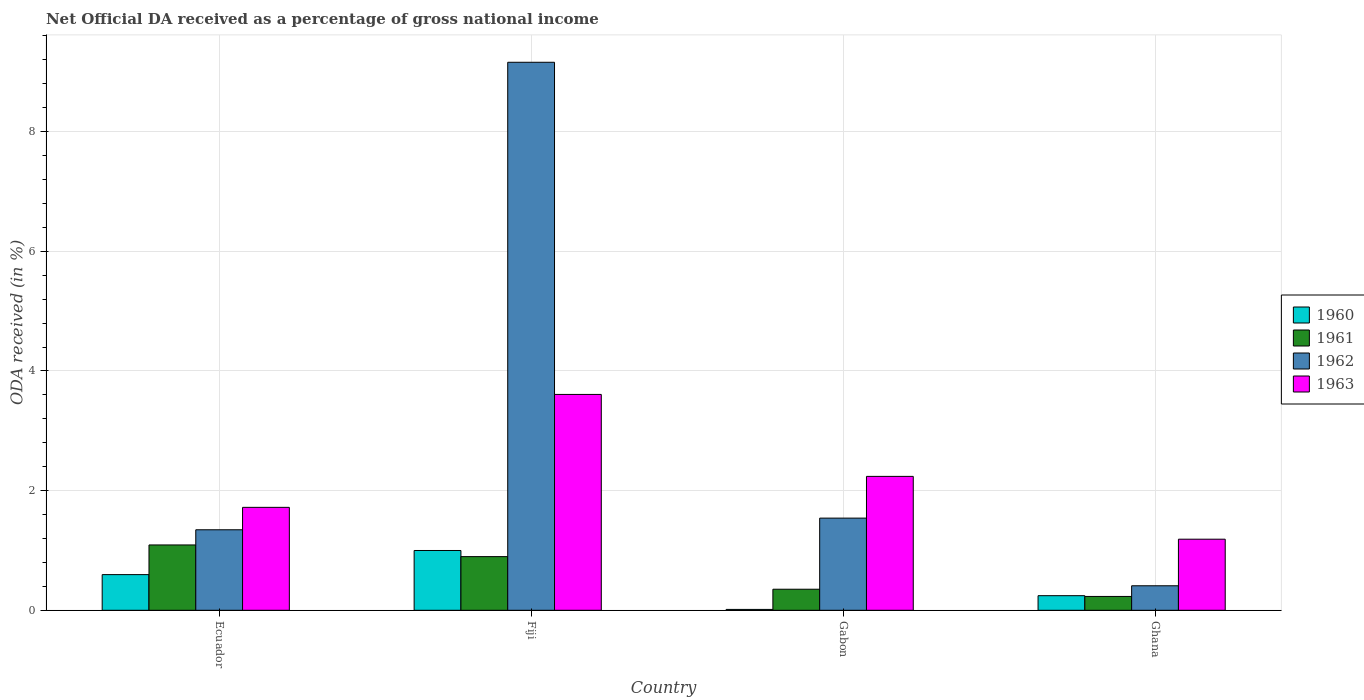How many different coloured bars are there?
Give a very brief answer. 4. Are the number of bars on each tick of the X-axis equal?
Keep it short and to the point. Yes. How many bars are there on the 3rd tick from the left?
Ensure brevity in your answer.  4. What is the label of the 3rd group of bars from the left?
Make the answer very short. Gabon. What is the net official DA received in 1962 in Ghana?
Ensure brevity in your answer.  0.41. Across all countries, what is the maximum net official DA received in 1961?
Ensure brevity in your answer.  1.09. Across all countries, what is the minimum net official DA received in 1962?
Your answer should be compact. 0.41. In which country was the net official DA received in 1960 maximum?
Your answer should be very brief. Fiji. What is the total net official DA received in 1961 in the graph?
Your answer should be compact. 2.57. What is the difference between the net official DA received in 1962 in Ecuador and that in Fiji?
Keep it short and to the point. -7.81. What is the difference between the net official DA received in 1962 in Ecuador and the net official DA received in 1960 in Gabon?
Give a very brief answer. 1.33. What is the average net official DA received in 1960 per country?
Ensure brevity in your answer.  0.46. What is the difference between the net official DA received of/in 1960 and net official DA received of/in 1962 in Gabon?
Your answer should be compact. -1.53. In how many countries, is the net official DA received in 1961 greater than 3.6 %?
Make the answer very short. 0. What is the ratio of the net official DA received in 1960 in Fiji to that in Ghana?
Provide a succinct answer. 4.09. What is the difference between the highest and the second highest net official DA received in 1960?
Offer a terse response. 0.4. What is the difference between the highest and the lowest net official DA received in 1961?
Give a very brief answer. 0.86. In how many countries, is the net official DA received in 1961 greater than the average net official DA received in 1961 taken over all countries?
Make the answer very short. 2. Is it the case that in every country, the sum of the net official DA received in 1962 and net official DA received in 1963 is greater than the net official DA received in 1961?
Provide a succinct answer. Yes. Are all the bars in the graph horizontal?
Give a very brief answer. No. What is the difference between two consecutive major ticks on the Y-axis?
Give a very brief answer. 2. Does the graph contain any zero values?
Provide a succinct answer. No. Does the graph contain grids?
Give a very brief answer. Yes. What is the title of the graph?
Offer a terse response. Net Official DA received as a percentage of gross national income. Does "1978" appear as one of the legend labels in the graph?
Provide a short and direct response. No. What is the label or title of the Y-axis?
Your answer should be compact. ODA received (in %). What is the ODA received (in %) of 1960 in Ecuador?
Your answer should be very brief. 0.6. What is the ODA received (in %) of 1961 in Ecuador?
Your answer should be very brief. 1.09. What is the ODA received (in %) of 1962 in Ecuador?
Your answer should be very brief. 1.35. What is the ODA received (in %) of 1963 in Ecuador?
Give a very brief answer. 1.72. What is the ODA received (in %) of 1960 in Fiji?
Offer a terse response. 1. What is the ODA received (in %) of 1961 in Fiji?
Ensure brevity in your answer.  0.9. What is the ODA received (in %) of 1962 in Fiji?
Provide a short and direct response. 9.16. What is the ODA received (in %) of 1963 in Fiji?
Give a very brief answer. 3.61. What is the ODA received (in %) of 1960 in Gabon?
Provide a short and direct response. 0.01. What is the ODA received (in %) in 1961 in Gabon?
Your answer should be compact. 0.35. What is the ODA received (in %) of 1962 in Gabon?
Make the answer very short. 1.54. What is the ODA received (in %) of 1963 in Gabon?
Offer a terse response. 2.24. What is the ODA received (in %) in 1960 in Ghana?
Make the answer very short. 0.24. What is the ODA received (in %) of 1961 in Ghana?
Your response must be concise. 0.23. What is the ODA received (in %) of 1962 in Ghana?
Provide a short and direct response. 0.41. What is the ODA received (in %) of 1963 in Ghana?
Ensure brevity in your answer.  1.19. Across all countries, what is the maximum ODA received (in %) in 1960?
Give a very brief answer. 1. Across all countries, what is the maximum ODA received (in %) in 1961?
Offer a very short reply. 1.09. Across all countries, what is the maximum ODA received (in %) in 1962?
Your answer should be very brief. 9.16. Across all countries, what is the maximum ODA received (in %) in 1963?
Keep it short and to the point. 3.61. Across all countries, what is the minimum ODA received (in %) of 1960?
Make the answer very short. 0.01. Across all countries, what is the minimum ODA received (in %) of 1961?
Offer a very short reply. 0.23. Across all countries, what is the minimum ODA received (in %) of 1962?
Your response must be concise. 0.41. Across all countries, what is the minimum ODA received (in %) of 1963?
Offer a terse response. 1.19. What is the total ODA received (in %) of 1960 in the graph?
Provide a short and direct response. 1.85. What is the total ODA received (in %) of 1961 in the graph?
Your answer should be very brief. 2.57. What is the total ODA received (in %) of 1962 in the graph?
Your answer should be very brief. 12.46. What is the total ODA received (in %) of 1963 in the graph?
Your answer should be compact. 8.76. What is the difference between the ODA received (in %) of 1960 in Ecuador and that in Fiji?
Offer a terse response. -0.4. What is the difference between the ODA received (in %) in 1961 in Ecuador and that in Fiji?
Give a very brief answer. 0.2. What is the difference between the ODA received (in %) of 1962 in Ecuador and that in Fiji?
Provide a short and direct response. -7.81. What is the difference between the ODA received (in %) in 1963 in Ecuador and that in Fiji?
Ensure brevity in your answer.  -1.89. What is the difference between the ODA received (in %) in 1960 in Ecuador and that in Gabon?
Your response must be concise. 0.58. What is the difference between the ODA received (in %) of 1961 in Ecuador and that in Gabon?
Provide a short and direct response. 0.74. What is the difference between the ODA received (in %) in 1962 in Ecuador and that in Gabon?
Ensure brevity in your answer.  -0.2. What is the difference between the ODA received (in %) of 1963 in Ecuador and that in Gabon?
Your answer should be compact. -0.52. What is the difference between the ODA received (in %) in 1960 in Ecuador and that in Ghana?
Provide a short and direct response. 0.35. What is the difference between the ODA received (in %) in 1961 in Ecuador and that in Ghana?
Make the answer very short. 0.86. What is the difference between the ODA received (in %) of 1962 in Ecuador and that in Ghana?
Offer a very short reply. 0.94. What is the difference between the ODA received (in %) in 1963 in Ecuador and that in Ghana?
Your answer should be compact. 0.53. What is the difference between the ODA received (in %) in 1960 in Fiji and that in Gabon?
Your response must be concise. 0.98. What is the difference between the ODA received (in %) of 1961 in Fiji and that in Gabon?
Your answer should be compact. 0.55. What is the difference between the ODA received (in %) in 1962 in Fiji and that in Gabon?
Your answer should be very brief. 7.62. What is the difference between the ODA received (in %) of 1963 in Fiji and that in Gabon?
Your answer should be compact. 1.37. What is the difference between the ODA received (in %) in 1960 in Fiji and that in Ghana?
Make the answer very short. 0.76. What is the difference between the ODA received (in %) in 1961 in Fiji and that in Ghana?
Your answer should be very brief. 0.67. What is the difference between the ODA received (in %) in 1962 in Fiji and that in Ghana?
Keep it short and to the point. 8.75. What is the difference between the ODA received (in %) of 1963 in Fiji and that in Ghana?
Keep it short and to the point. 2.42. What is the difference between the ODA received (in %) in 1960 in Gabon and that in Ghana?
Provide a short and direct response. -0.23. What is the difference between the ODA received (in %) in 1961 in Gabon and that in Ghana?
Your answer should be compact. 0.12. What is the difference between the ODA received (in %) of 1962 in Gabon and that in Ghana?
Offer a terse response. 1.13. What is the difference between the ODA received (in %) of 1963 in Gabon and that in Ghana?
Your answer should be compact. 1.05. What is the difference between the ODA received (in %) in 1960 in Ecuador and the ODA received (in %) in 1961 in Fiji?
Your answer should be compact. -0.3. What is the difference between the ODA received (in %) of 1960 in Ecuador and the ODA received (in %) of 1962 in Fiji?
Provide a short and direct response. -8.56. What is the difference between the ODA received (in %) of 1960 in Ecuador and the ODA received (in %) of 1963 in Fiji?
Provide a succinct answer. -3.01. What is the difference between the ODA received (in %) in 1961 in Ecuador and the ODA received (in %) in 1962 in Fiji?
Your response must be concise. -8.07. What is the difference between the ODA received (in %) of 1961 in Ecuador and the ODA received (in %) of 1963 in Fiji?
Ensure brevity in your answer.  -2.52. What is the difference between the ODA received (in %) of 1962 in Ecuador and the ODA received (in %) of 1963 in Fiji?
Offer a very short reply. -2.26. What is the difference between the ODA received (in %) in 1960 in Ecuador and the ODA received (in %) in 1961 in Gabon?
Make the answer very short. 0.24. What is the difference between the ODA received (in %) in 1960 in Ecuador and the ODA received (in %) in 1962 in Gabon?
Provide a short and direct response. -0.94. What is the difference between the ODA received (in %) in 1960 in Ecuador and the ODA received (in %) in 1963 in Gabon?
Ensure brevity in your answer.  -1.64. What is the difference between the ODA received (in %) of 1961 in Ecuador and the ODA received (in %) of 1962 in Gabon?
Keep it short and to the point. -0.45. What is the difference between the ODA received (in %) of 1961 in Ecuador and the ODA received (in %) of 1963 in Gabon?
Offer a terse response. -1.15. What is the difference between the ODA received (in %) in 1962 in Ecuador and the ODA received (in %) in 1963 in Gabon?
Your answer should be very brief. -0.89. What is the difference between the ODA received (in %) of 1960 in Ecuador and the ODA received (in %) of 1961 in Ghana?
Provide a short and direct response. 0.36. What is the difference between the ODA received (in %) in 1960 in Ecuador and the ODA received (in %) in 1962 in Ghana?
Give a very brief answer. 0.19. What is the difference between the ODA received (in %) of 1960 in Ecuador and the ODA received (in %) of 1963 in Ghana?
Offer a terse response. -0.59. What is the difference between the ODA received (in %) of 1961 in Ecuador and the ODA received (in %) of 1962 in Ghana?
Provide a succinct answer. 0.68. What is the difference between the ODA received (in %) of 1961 in Ecuador and the ODA received (in %) of 1963 in Ghana?
Offer a very short reply. -0.1. What is the difference between the ODA received (in %) of 1962 in Ecuador and the ODA received (in %) of 1963 in Ghana?
Keep it short and to the point. 0.16. What is the difference between the ODA received (in %) in 1960 in Fiji and the ODA received (in %) in 1961 in Gabon?
Give a very brief answer. 0.65. What is the difference between the ODA received (in %) of 1960 in Fiji and the ODA received (in %) of 1962 in Gabon?
Give a very brief answer. -0.54. What is the difference between the ODA received (in %) in 1960 in Fiji and the ODA received (in %) in 1963 in Gabon?
Your answer should be compact. -1.24. What is the difference between the ODA received (in %) of 1961 in Fiji and the ODA received (in %) of 1962 in Gabon?
Give a very brief answer. -0.64. What is the difference between the ODA received (in %) in 1961 in Fiji and the ODA received (in %) in 1963 in Gabon?
Your response must be concise. -1.34. What is the difference between the ODA received (in %) in 1962 in Fiji and the ODA received (in %) in 1963 in Gabon?
Offer a terse response. 6.92. What is the difference between the ODA received (in %) of 1960 in Fiji and the ODA received (in %) of 1961 in Ghana?
Your answer should be very brief. 0.77. What is the difference between the ODA received (in %) of 1960 in Fiji and the ODA received (in %) of 1962 in Ghana?
Your response must be concise. 0.59. What is the difference between the ODA received (in %) in 1960 in Fiji and the ODA received (in %) in 1963 in Ghana?
Keep it short and to the point. -0.19. What is the difference between the ODA received (in %) of 1961 in Fiji and the ODA received (in %) of 1962 in Ghana?
Keep it short and to the point. 0.49. What is the difference between the ODA received (in %) of 1961 in Fiji and the ODA received (in %) of 1963 in Ghana?
Ensure brevity in your answer.  -0.29. What is the difference between the ODA received (in %) of 1962 in Fiji and the ODA received (in %) of 1963 in Ghana?
Your response must be concise. 7.97. What is the difference between the ODA received (in %) in 1960 in Gabon and the ODA received (in %) in 1961 in Ghana?
Your response must be concise. -0.22. What is the difference between the ODA received (in %) of 1960 in Gabon and the ODA received (in %) of 1962 in Ghana?
Your answer should be compact. -0.4. What is the difference between the ODA received (in %) in 1960 in Gabon and the ODA received (in %) in 1963 in Ghana?
Your answer should be compact. -1.17. What is the difference between the ODA received (in %) of 1961 in Gabon and the ODA received (in %) of 1962 in Ghana?
Your answer should be compact. -0.06. What is the difference between the ODA received (in %) of 1961 in Gabon and the ODA received (in %) of 1963 in Ghana?
Offer a very short reply. -0.84. What is the difference between the ODA received (in %) of 1962 in Gabon and the ODA received (in %) of 1963 in Ghana?
Offer a very short reply. 0.35. What is the average ODA received (in %) of 1960 per country?
Your answer should be compact. 0.46. What is the average ODA received (in %) of 1961 per country?
Make the answer very short. 0.64. What is the average ODA received (in %) in 1962 per country?
Provide a short and direct response. 3.11. What is the average ODA received (in %) in 1963 per country?
Offer a terse response. 2.19. What is the difference between the ODA received (in %) of 1960 and ODA received (in %) of 1961 in Ecuador?
Provide a succinct answer. -0.5. What is the difference between the ODA received (in %) in 1960 and ODA received (in %) in 1962 in Ecuador?
Ensure brevity in your answer.  -0.75. What is the difference between the ODA received (in %) in 1960 and ODA received (in %) in 1963 in Ecuador?
Your answer should be very brief. -1.12. What is the difference between the ODA received (in %) in 1961 and ODA received (in %) in 1962 in Ecuador?
Your response must be concise. -0.25. What is the difference between the ODA received (in %) in 1961 and ODA received (in %) in 1963 in Ecuador?
Provide a short and direct response. -0.63. What is the difference between the ODA received (in %) of 1962 and ODA received (in %) of 1963 in Ecuador?
Offer a terse response. -0.37. What is the difference between the ODA received (in %) of 1960 and ODA received (in %) of 1961 in Fiji?
Your answer should be compact. 0.1. What is the difference between the ODA received (in %) of 1960 and ODA received (in %) of 1962 in Fiji?
Your answer should be compact. -8.16. What is the difference between the ODA received (in %) in 1960 and ODA received (in %) in 1963 in Fiji?
Provide a succinct answer. -2.61. What is the difference between the ODA received (in %) of 1961 and ODA received (in %) of 1962 in Fiji?
Ensure brevity in your answer.  -8.26. What is the difference between the ODA received (in %) of 1961 and ODA received (in %) of 1963 in Fiji?
Ensure brevity in your answer.  -2.71. What is the difference between the ODA received (in %) of 1962 and ODA received (in %) of 1963 in Fiji?
Ensure brevity in your answer.  5.55. What is the difference between the ODA received (in %) in 1960 and ODA received (in %) in 1961 in Gabon?
Keep it short and to the point. -0.34. What is the difference between the ODA received (in %) in 1960 and ODA received (in %) in 1962 in Gabon?
Provide a short and direct response. -1.53. What is the difference between the ODA received (in %) of 1960 and ODA received (in %) of 1963 in Gabon?
Make the answer very short. -2.22. What is the difference between the ODA received (in %) of 1961 and ODA received (in %) of 1962 in Gabon?
Your response must be concise. -1.19. What is the difference between the ODA received (in %) of 1961 and ODA received (in %) of 1963 in Gabon?
Provide a short and direct response. -1.89. What is the difference between the ODA received (in %) of 1962 and ODA received (in %) of 1963 in Gabon?
Make the answer very short. -0.7. What is the difference between the ODA received (in %) of 1960 and ODA received (in %) of 1961 in Ghana?
Provide a succinct answer. 0.01. What is the difference between the ODA received (in %) in 1960 and ODA received (in %) in 1962 in Ghana?
Give a very brief answer. -0.17. What is the difference between the ODA received (in %) in 1960 and ODA received (in %) in 1963 in Ghana?
Offer a very short reply. -0.94. What is the difference between the ODA received (in %) in 1961 and ODA received (in %) in 1962 in Ghana?
Your answer should be compact. -0.18. What is the difference between the ODA received (in %) in 1961 and ODA received (in %) in 1963 in Ghana?
Keep it short and to the point. -0.96. What is the difference between the ODA received (in %) in 1962 and ODA received (in %) in 1963 in Ghana?
Offer a terse response. -0.78. What is the ratio of the ODA received (in %) of 1960 in Ecuador to that in Fiji?
Offer a terse response. 0.6. What is the ratio of the ODA received (in %) in 1961 in Ecuador to that in Fiji?
Your answer should be compact. 1.22. What is the ratio of the ODA received (in %) in 1962 in Ecuador to that in Fiji?
Make the answer very short. 0.15. What is the ratio of the ODA received (in %) of 1963 in Ecuador to that in Fiji?
Provide a short and direct response. 0.48. What is the ratio of the ODA received (in %) of 1960 in Ecuador to that in Gabon?
Offer a very short reply. 40.19. What is the ratio of the ODA received (in %) of 1961 in Ecuador to that in Gabon?
Offer a very short reply. 3.1. What is the ratio of the ODA received (in %) in 1962 in Ecuador to that in Gabon?
Your answer should be very brief. 0.87. What is the ratio of the ODA received (in %) of 1963 in Ecuador to that in Gabon?
Your response must be concise. 0.77. What is the ratio of the ODA received (in %) in 1960 in Ecuador to that in Ghana?
Offer a terse response. 2.44. What is the ratio of the ODA received (in %) in 1961 in Ecuador to that in Ghana?
Ensure brevity in your answer.  4.72. What is the ratio of the ODA received (in %) in 1962 in Ecuador to that in Ghana?
Keep it short and to the point. 3.28. What is the ratio of the ODA received (in %) of 1963 in Ecuador to that in Ghana?
Your answer should be very brief. 1.45. What is the ratio of the ODA received (in %) of 1960 in Fiji to that in Gabon?
Keep it short and to the point. 67.36. What is the ratio of the ODA received (in %) in 1961 in Fiji to that in Gabon?
Provide a short and direct response. 2.55. What is the ratio of the ODA received (in %) in 1962 in Fiji to that in Gabon?
Ensure brevity in your answer.  5.94. What is the ratio of the ODA received (in %) of 1963 in Fiji to that in Gabon?
Provide a succinct answer. 1.61. What is the ratio of the ODA received (in %) of 1960 in Fiji to that in Ghana?
Offer a very short reply. 4.09. What is the ratio of the ODA received (in %) in 1961 in Fiji to that in Ghana?
Your answer should be very brief. 3.88. What is the ratio of the ODA received (in %) of 1962 in Fiji to that in Ghana?
Provide a succinct answer. 22.34. What is the ratio of the ODA received (in %) in 1963 in Fiji to that in Ghana?
Keep it short and to the point. 3.04. What is the ratio of the ODA received (in %) of 1960 in Gabon to that in Ghana?
Your answer should be very brief. 0.06. What is the ratio of the ODA received (in %) in 1961 in Gabon to that in Ghana?
Provide a short and direct response. 1.52. What is the ratio of the ODA received (in %) of 1962 in Gabon to that in Ghana?
Offer a very short reply. 3.76. What is the ratio of the ODA received (in %) in 1963 in Gabon to that in Ghana?
Your answer should be compact. 1.88. What is the difference between the highest and the second highest ODA received (in %) of 1960?
Give a very brief answer. 0.4. What is the difference between the highest and the second highest ODA received (in %) of 1961?
Offer a terse response. 0.2. What is the difference between the highest and the second highest ODA received (in %) of 1962?
Make the answer very short. 7.62. What is the difference between the highest and the second highest ODA received (in %) in 1963?
Your response must be concise. 1.37. What is the difference between the highest and the lowest ODA received (in %) of 1960?
Provide a succinct answer. 0.98. What is the difference between the highest and the lowest ODA received (in %) of 1961?
Provide a short and direct response. 0.86. What is the difference between the highest and the lowest ODA received (in %) in 1962?
Offer a terse response. 8.75. What is the difference between the highest and the lowest ODA received (in %) of 1963?
Your answer should be very brief. 2.42. 